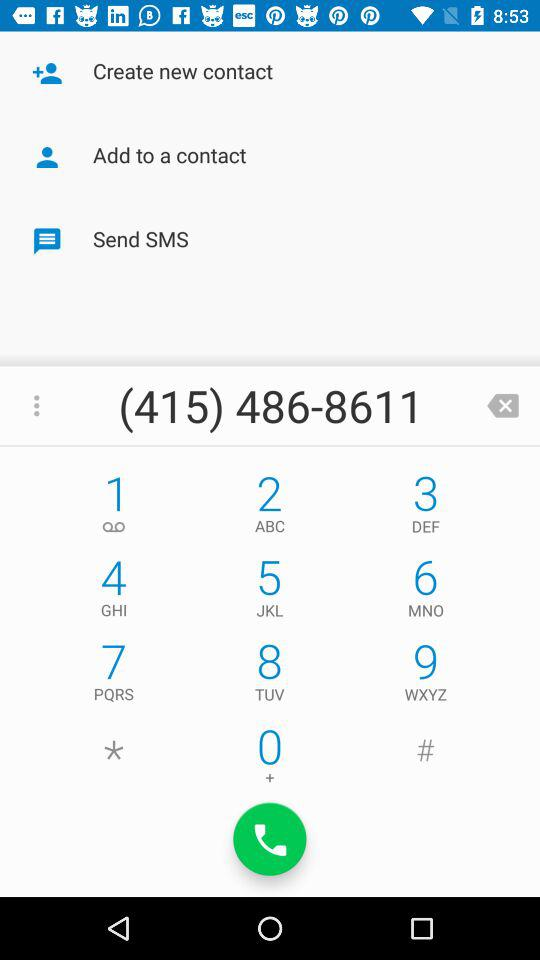What is the name of the contact?
When the provided information is insufficient, respond with <no answer>. <no answer> 